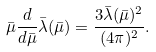Convert formula to latex. <formula><loc_0><loc_0><loc_500><loc_500>\bar { \mu } \frac { d } { d \bar { \mu } } \bar { \lambda } ( \bar { \mu } ) = \frac { 3 \bar { \lambda } ( \bar { \mu } ) ^ { 2 } } { ( 4 \pi ) ^ { 2 } } .</formula> 